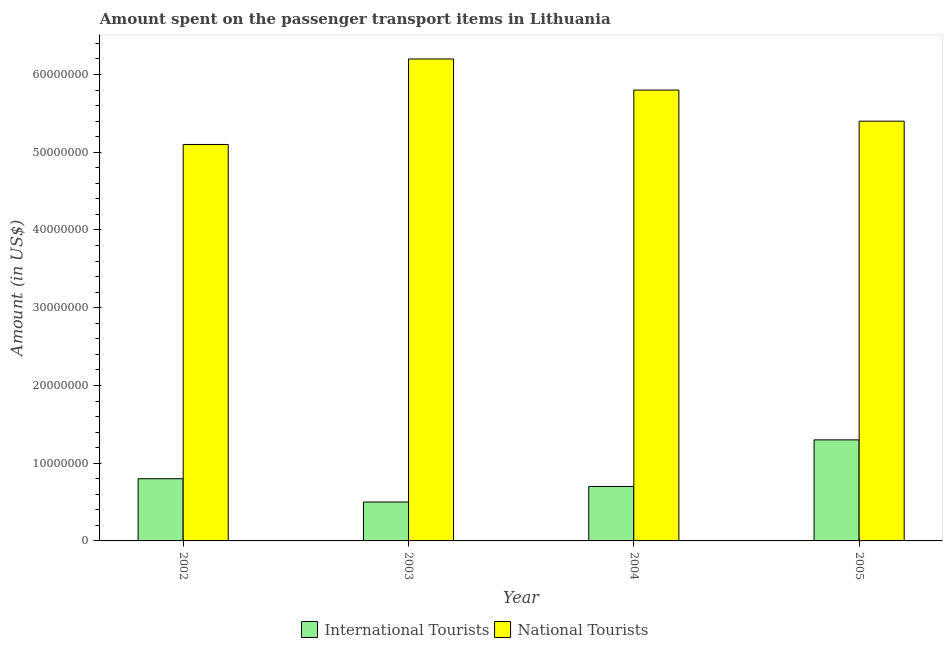How many different coloured bars are there?
Your answer should be very brief. 2. What is the amount spent on transport items of national tourists in 2004?
Give a very brief answer. 5.80e+07. Across all years, what is the maximum amount spent on transport items of national tourists?
Provide a short and direct response. 6.20e+07. Across all years, what is the minimum amount spent on transport items of international tourists?
Your response must be concise. 5.00e+06. In which year was the amount spent on transport items of international tourists minimum?
Keep it short and to the point. 2003. What is the total amount spent on transport items of international tourists in the graph?
Give a very brief answer. 3.30e+07. What is the difference between the amount spent on transport items of national tourists in 2002 and that in 2003?
Your answer should be compact. -1.10e+07. What is the difference between the amount spent on transport items of international tourists in 2003 and the amount spent on transport items of national tourists in 2005?
Make the answer very short. -8.00e+06. What is the average amount spent on transport items of national tourists per year?
Provide a short and direct response. 5.62e+07. In how many years, is the amount spent on transport items of national tourists greater than 16000000 US$?
Offer a terse response. 4. What is the ratio of the amount spent on transport items of international tourists in 2002 to that in 2005?
Offer a terse response. 0.62. Is the amount spent on transport items of international tourists in 2003 less than that in 2005?
Provide a short and direct response. Yes. Is the difference between the amount spent on transport items of international tourists in 2003 and 2004 greater than the difference between the amount spent on transport items of national tourists in 2003 and 2004?
Make the answer very short. No. What is the difference between the highest and the lowest amount spent on transport items of international tourists?
Ensure brevity in your answer.  8.00e+06. In how many years, is the amount spent on transport items of national tourists greater than the average amount spent on transport items of national tourists taken over all years?
Ensure brevity in your answer.  2. Is the sum of the amount spent on transport items of national tourists in 2004 and 2005 greater than the maximum amount spent on transport items of international tourists across all years?
Your answer should be compact. Yes. What does the 2nd bar from the left in 2002 represents?
Ensure brevity in your answer.  National Tourists. What does the 2nd bar from the right in 2004 represents?
Your answer should be very brief. International Tourists. How many bars are there?
Offer a very short reply. 8. What is the difference between two consecutive major ticks on the Y-axis?
Offer a very short reply. 1.00e+07. Does the graph contain any zero values?
Provide a succinct answer. No. Does the graph contain grids?
Offer a very short reply. No. Where does the legend appear in the graph?
Offer a very short reply. Bottom center. How many legend labels are there?
Provide a succinct answer. 2. How are the legend labels stacked?
Make the answer very short. Horizontal. What is the title of the graph?
Offer a terse response. Amount spent on the passenger transport items in Lithuania. What is the label or title of the X-axis?
Provide a short and direct response. Year. What is the label or title of the Y-axis?
Your answer should be compact. Amount (in US$). What is the Amount (in US$) in International Tourists in 2002?
Your answer should be very brief. 8.00e+06. What is the Amount (in US$) of National Tourists in 2002?
Offer a terse response. 5.10e+07. What is the Amount (in US$) in National Tourists in 2003?
Provide a short and direct response. 6.20e+07. What is the Amount (in US$) of International Tourists in 2004?
Give a very brief answer. 7.00e+06. What is the Amount (in US$) of National Tourists in 2004?
Offer a terse response. 5.80e+07. What is the Amount (in US$) in International Tourists in 2005?
Offer a very short reply. 1.30e+07. What is the Amount (in US$) of National Tourists in 2005?
Make the answer very short. 5.40e+07. Across all years, what is the maximum Amount (in US$) in International Tourists?
Give a very brief answer. 1.30e+07. Across all years, what is the maximum Amount (in US$) in National Tourists?
Your response must be concise. 6.20e+07. Across all years, what is the minimum Amount (in US$) of International Tourists?
Provide a short and direct response. 5.00e+06. Across all years, what is the minimum Amount (in US$) in National Tourists?
Offer a very short reply. 5.10e+07. What is the total Amount (in US$) of International Tourists in the graph?
Your response must be concise. 3.30e+07. What is the total Amount (in US$) of National Tourists in the graph?
Keep it short and to the point. 2.25e+08. What is the difference between the Amount (in US$) of National Tourists in 2002 and that in 2003?
Keep it short and to the point. -1.10e+07. What is the difference between the Amount (in US$) of National Tourists in 2002 and that in 2004?
Your answer should be very brief. -7.00e+06. What is the difference between the Amount (in US$) in International Tourists in 2002 and that in 2005?
Ensure brevity in your answer.  -5.00e+06. What is the difference between the Amount (in US$) of National Tourists in 2003 and that in 2004?
Your response must be concise. 4.00e+06. What is the difference between the Amount (in US$) of International Tourists in 2003 and that in 2005?
Make the answer very short. -8.00e+06. What is the difference between the Amount (in US$) in International Tourists in 2004 and that in 2005?
Your answer should be compact. -6.00e+06. What is the difference between the Amount (in US$) of National Tourists in 2004 and that in 2005?
Offer a very short reply. 4.00e+06. What is the difference between the Amount (in US$) in International Tourists in 2002 and the Amount (in US$) in National Tourists in 2003?
Offer a terse response. -5.40e+07. What is the difference between the Amount (in US$) in International Tourists in 2002 and the Amount (in US$) in National Tourists in 2004?
Provide a short and direct response. -5.00e+07. What is the difference between the Amount (in US$) of International Tourists in 2002 and the Amount (in US$) of National Tourists in 2005?
Make the answer very short. -4.60e+07. What is the difference between the Amount (in US$) in International Tourists in 2003 and the Amount (in US$) in National Tourists in 2004?
Keep it short and to the point. -5.30e+07. What is the difference between the Amount (in US$) in International Tourists in 2003 and the Amount (in US$) in National Tourists in 2005?
Offer a terse response. -4.90e+07. What is the difference between the Amount (in US$) of International Tourists in 2004 and the Amount (in US$) of National Tourists in 2005?
Offer a very short reply. -4.70e+07. What is the average Amount (in US$) in International Tourists per year?
Give a very brief answer. 8.25e+06. What is the average Amount (in US$) in National Tourists per year?
Your response must be concise. 5.62e+07. In the year 2002, what is the difference between the Amount (in US$) in International Tourists and Amount (in US$) in National Tourists?
Offer a terse response. -4.30e+07. In the year 2003, what is the difference between the Amount (in US$) in International Tourists and Amount (in US$) in National Tourists?
Ensure brevity in your answer.  -5.70e+07. In the year 2004, what is the difference between the Amount (in US$) in International Tourists and Amount (in US$) in National Tourists?
Give a very brief answer. -5.10e+07. In the year 2005, what is the difference between the Amount (in US$) in International Tourists and Amount (in US$) in National Tourists?
Offer a very short reply. -4.10e+07. What is the ratio of the Amount (in US$) in National Tourists in 2002 to that in 2003?
Offer a terse response. 0.82. What is the ratio of the Amount (in US$) of National Tourists in 2002 to that in 2004?
Keep it short and to the point. 0.88. What is the ratio of the Amount (in US$) in International Tourists in 2002 to that in 2005?
Ensure brevity in your answer.  0.62. What is the ratio of the Amount (in US$) in International Tourists in 2003 to that in 2004?
Offer a very short reply. 0.71. What is the ratio of the Amount (in US$) of National Tourists in 2003 to that in 2004?
Offer a terse response. 1.07. What is the ratio of the Amount (in US$) of International Tourists in 2003 to that in 2005?
Your response must be concise. 0.38. What is the ratio of the Amount (in US$) in National Tourists in 2003 to that in 2005?
Make the answer very short. 1.15. What is the ratio of the Amount (in US$) in International Tourists in 2004 to that in 2005?
Give a very brief answer. 0.54. What is the ratio of the Amount (in US$) of National Tourists in 2004 to that in 2005?
Offer a very short reply. 1.07. What is the difference between the highest and the lowest Amount (in US$) in International Tourists?
Provide a short and direct response. 8.00e+06. What is the difference between the highest and the lowest Amount (in US$) in National Tourists?
Make the answer very short. 1.10e+07. 